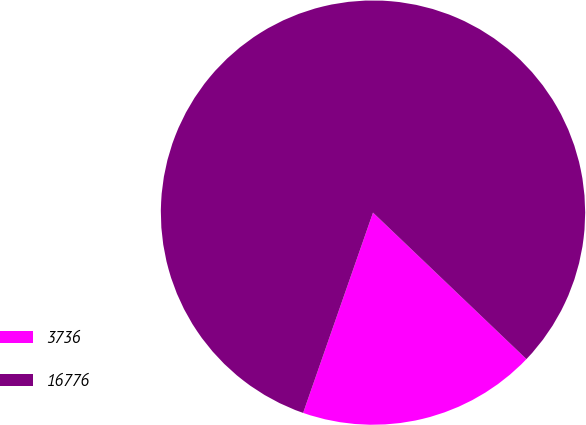<chart> <loc_0><loc_0><loc_500><loc_500><pie_chart><fcel>3736<fcel>16776<nl><fcel>18.21%<fcel>81.79%<nl></chart> 